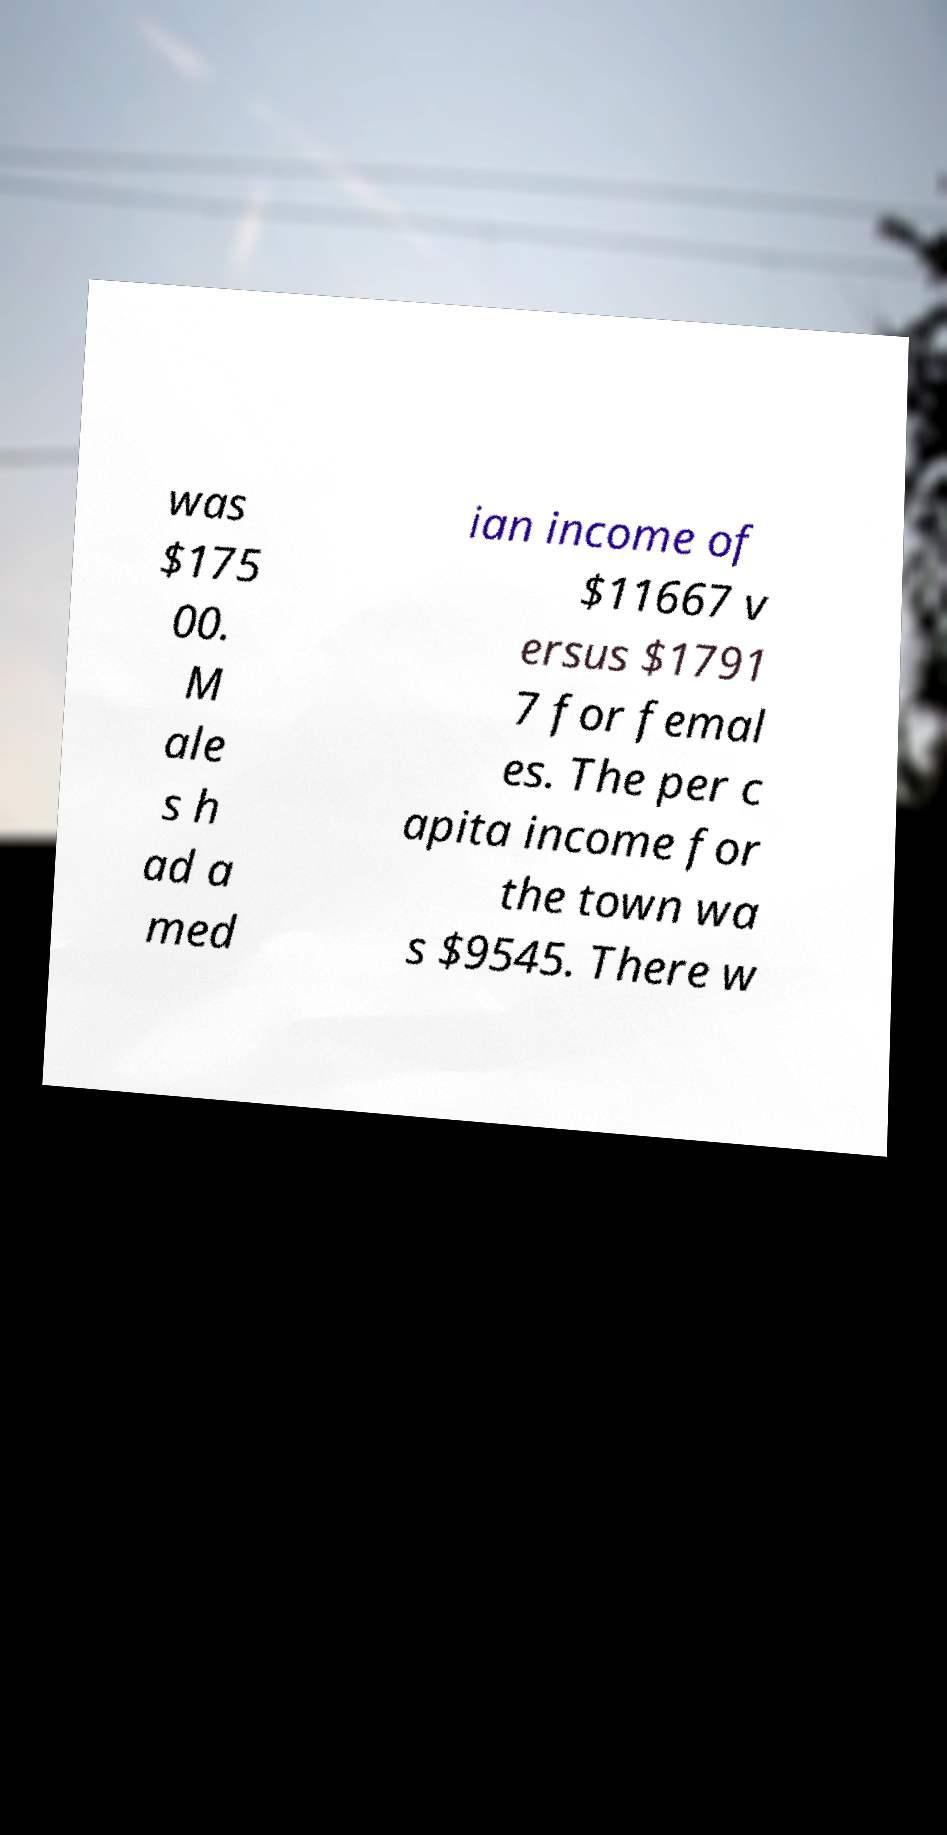Please read and relay the text visible in this image. What does it say? was $175 00. M ale s h ad a med ian income of $11667 v ersus $1791 7 for femal es. The per c apita income for the town wa s $9545. There w 